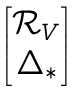Convert formula to latex. <formula><loc_0><loc_0><loc_500><loc_500>\begin{bmatrix} { \mathcal { R } } _ { V } \\ \Delta _ { * } \end{bmatrix}</formula> 